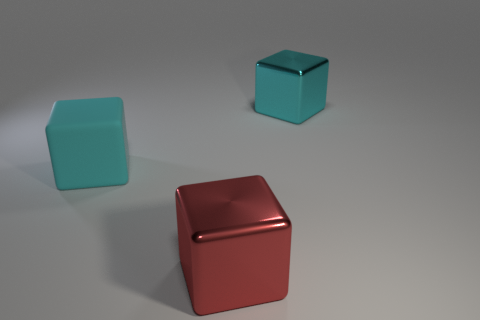Are there any other things that have the same size as the matte object?
Give a very brief answer. Yes. What is the shape of the large metallic thing that is the same color as the rubber thing?
Your response must be concise. Cube. What number of blocks are either cyan rubber things or red metallic things?
Offer a very short reply. 2. Are there the same number of large cubes on the left side of the large red thing and red shiny objects behind the big cyan metallic cube?
Provide a succinct answer. No. There is a red object that is the same shape as the cyan metal object; what is its size?
Keep it short and to the point. Large. How big is the block that is in front of the cyan shiny thing and right of the cyan matte thing?
Provide a short and direct response. Large. Are there any cyan matte cubes in front of the big cyan shiny cube?
Ensure brevity in your answer.  Yes. What number of things are either cyan things that are left of the cyan shiny cube or large blue metal cylinders?
Give a very brief answer. 1. There is a big metallic object that is in front of the cyan matte block; how many large cubes are on the left side of it?
Offer a very short reply. 1. Is the number of large metal blocks behind the red metal block less than the number of objects in front of the cyan metallic object?
Ensure brevity in your answer.  Yes. 